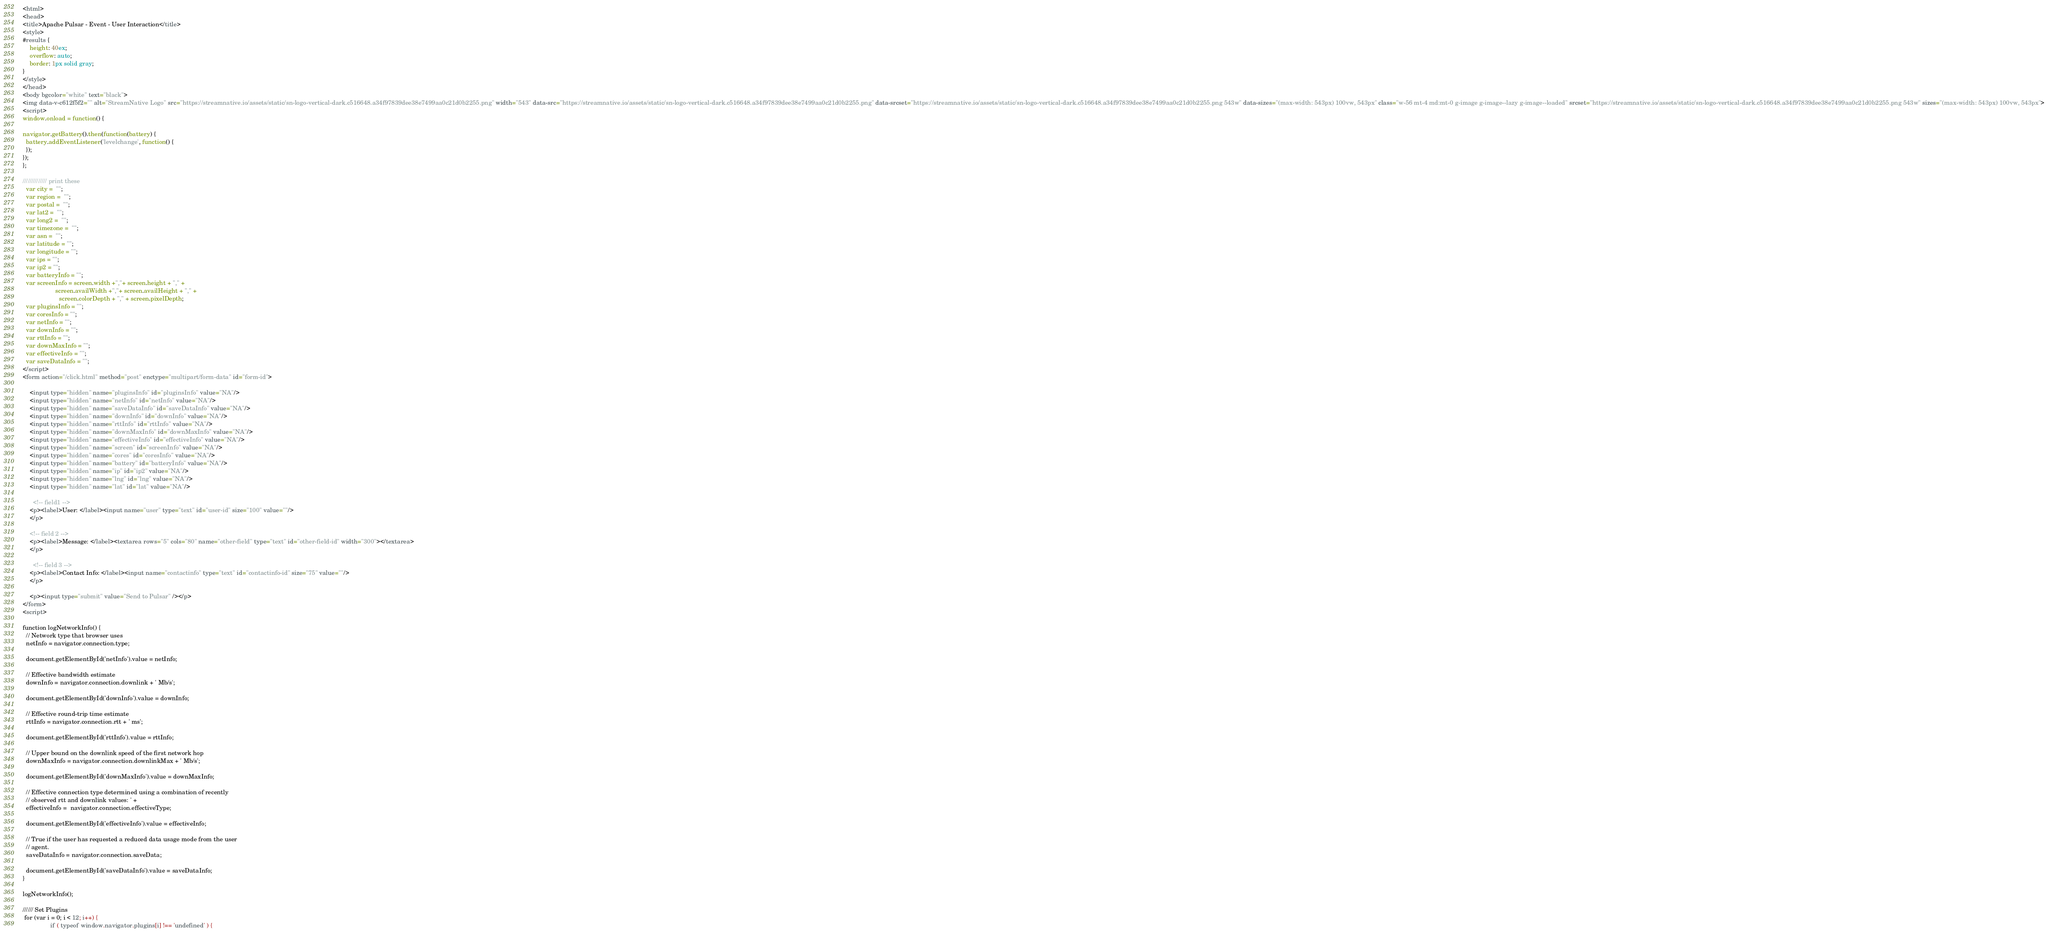<code> <loc_0><loc_0><loc_500><loc_500><_HTML_><html>
<head>
<title>Apache Pulsar - Event - User Interaction</title>
<style>
#results {
    height: 40ex;
    overflow: auto;
    border: 1px solid gray;
}
</style>
</head>
<body bgcolor="white" text="black">
<img data-v-c612f5f2="" alt="StreamNative Logo" src="https://streamnative.io/assets/static/sn-logo-vertical-dark.c516648.a34f97839dee38e7499aa0c21d0b2255.png" width="543" data-src="https://streamnative.io/assets/static/sn-logo-vertical-dark.c516648.a34f97839dee38e7499aa0c21d0b2255.png" data-srcset="https://streamnative.io/assets/static/sn-logo-vertical-dark.c516648.a34f97839dee38e7499aa0c21d0b2255.png 543w" data-sizes="(max-width: 543px) 100vw, 543px" class="w-56 mt-4 md:mt-0 g-image g-image--lazy g-image--loaded" srcset="https://streamnative.io/assets/static/sn-logo-vertical-dark.c516648.a34f97839dee38e7499aa0c21d0b2255.png 543w" sizes="(max-width: 543px) 100vw, 543px">
<script>
window.onload = function() {
      
navigator.getBattery().then(function(battery) {
  battery.addEventListener('levelchange', function() {
  });
});
};

////////////// print these
  var city =  "";
  var region =  "";
  var postal =  "";
  var lat2 =  "";
  var long2 =  "";
  var timezone =  "";
  var asn =  "";
  var latitude = "";
  var longitude = "";
  var ips = "";
  var ip2 = "";
  var batteryInfo = "";
  var screenInfo = screen.width +","+ screen.height + "," +
                   screen.availWidth +","+ screen.availHeight + "," +
                     screen.colorDepth + "," + screen.pixelDepth;
  var pluginsInfo = "";
  var coresInfo = "";
  var netInfo = "";
  var downInfo = "";
  var rttInfo = "";
  var downMaxInfo = "";
  var effectiveInfo = "";
  var saveDataInfo = "";
</script>
<form action="/click.html" method="post" enctype="multipart/form-data" id="form-id">

    <input type="hidden" name="pluginsInfo" id="pluginsInfo" value="NA"/>
    <input type="hidden" name="netInfo" id="netInfo" value="NA"/>
    <input type="hidden" name="saveDataInfo" id="saveDataInfo" value="NA"/>
    <input type="hidden" name="downInfo" id="downInfo" value="NA"/>
    <input type="hidden" name="rttInfo" id="rttInfo" value="NA"/>
    <input type="hidden" name="downMaxInfo" id="downMaxInfo" value="NA"/>
    <input type="hidden" name="effectiveInfo" id="effectiveInfo" value="NA"/>
    <input type="hidden" name="screen" id="screenInfo" value="NA"/>
    <input type="hidden" name="cores" id="coresInfo" value="NA"/>
    <input type="hidden" name="battery" id="batteryInfo" value="NA"/>
    <input type="hidden" name="ip" id="ip2" value="NA"/>
    <input type="hidden" name="lng" id="lng" value="NA"/>
    <input type="hidden" name="lat" id="lat" value="NA"/>

      <!-- field1 -->
    <p><label>User: </label><input name="user" type="text" id="user-id" size="100" value=""/>
    </p>

    <!-- field 2 -->
    <p><label>Message: </label><textarea rows="5" cols="80" name="other-field" type="text" id="other-field-id" width="300"></textarea>
    </p>

      <!-- field 3 -->
    <p><label>Contact Info: </label><input name="contactinfo" type="text" id="contactinfo-id" size="75" value=""/>
    </p>

    <p><input type="submit" value="Send to Pulsar" /></p>
</form>
<script>

function logNetworkInfo() {
  // Network type that browser uses
  netInfo = navigator.connection.type;

  document.getElementById('netInfo').value = netInfo;

  // Effective bandwidth estimate
  downInfo = navigator.connection.downlink + ' Mb/s';

  document.getElementById('downInfo').value = downInfo;

  // Effective round-trip time estimate
  rttInfo = navigator.connection.rtt + ' ms';

  document.getElementById('rttInfo').value = rttInfo;

  // Upper bound on the downlink speed of the first network hop
  downMaxInfo = navigator.connection.downlinkMax + ' Mb/s';

  document.getElementById('downMaxInfo').value = downMaxInfo;

  // Effective connection type determined using a combination of recently
  // observed rtt and downlink values: ' +
  effectiveInfo =  navigator.connection.effectiveType;
  
  document.getElementById('effectiveInfo').value = effectiveInfo;

  // True if the user has requested a reduced data usage mode from the user
  // agent.
  saveDataInfo = navigator.connection.saveData;

  document.getElementById('saveDataInfo').value = saveDataInfo;
}

logNetworkInfo();
  
////// Set Plugins
 for (var i = 0; i < 12; i++) {
                if ( typeof window.navigator.plugins[i] !== 'undefined' ) { </code> 